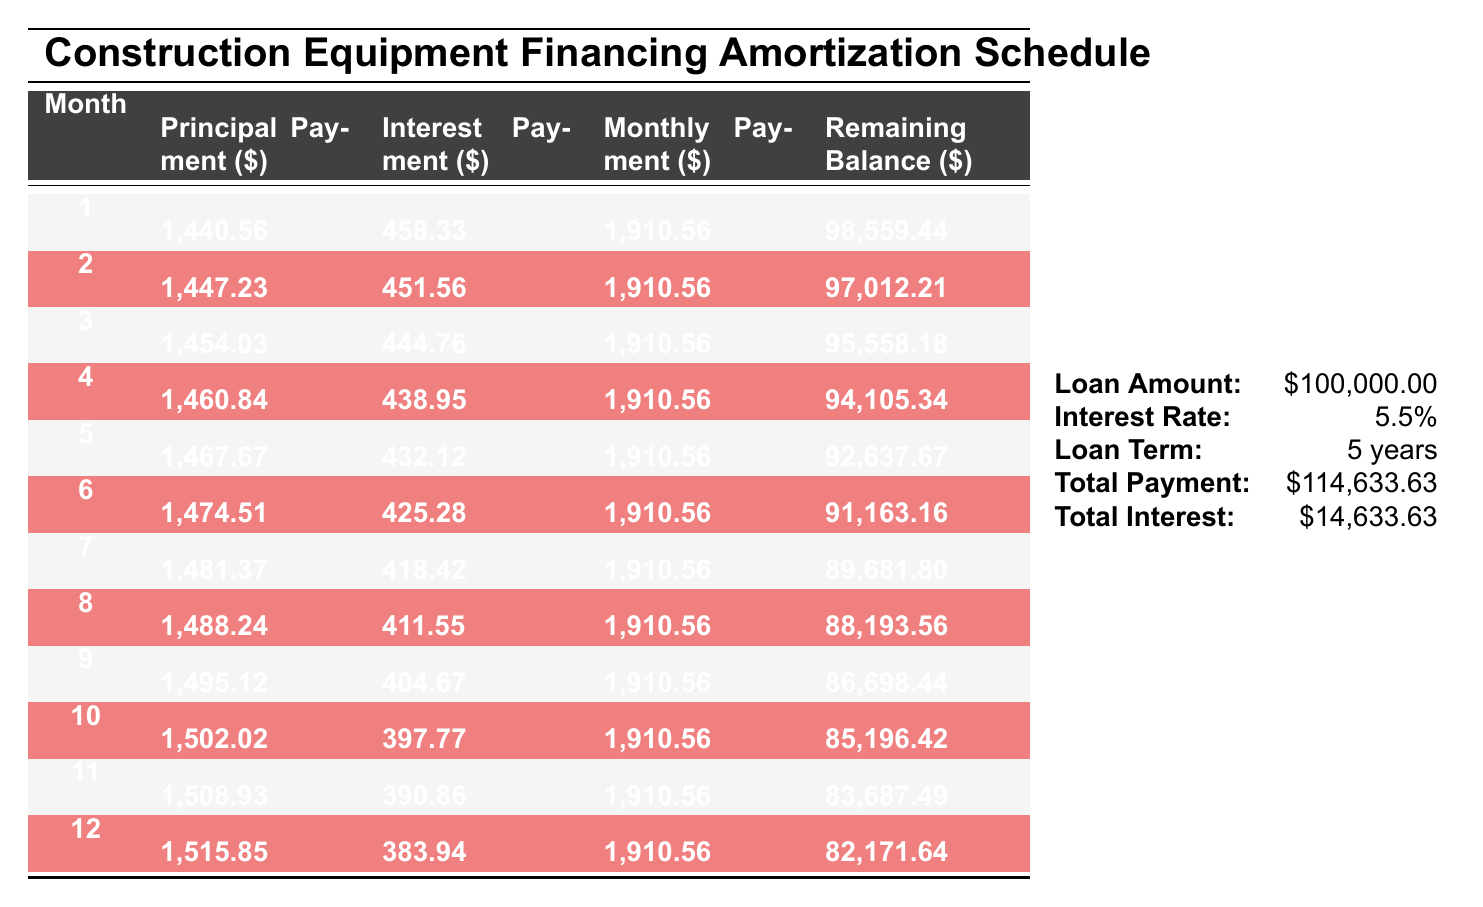What is the total amount paid by the end of the loan? The total amount paid is mentioned in the bottom table as $114,633.63.
Answer: 114,633.63 What is the interest payment for the first month? The interest payment for the first month is shown in the table as $458.33.
Answer: 458.33 How much principal is paid in the sixth month? The principal payment for the sixth month is indicated as $1,474.51 in the table.
Answer: 1,474.51 Is the interest payment decreasing each month? By looking at the interest payments across the months in the table, we see values starting from $458.33 in month 1 and decreasing consistently to $383.94 in month 12, confirming the trend of decreasing interest payments.
Answer: Yes What is the average monthly principal payment over the first 12 months? To calculate the average, sum the principal payments for the first 12 months: (1,440.56 + 1,447.23 + 1,454.03 + ... + 1,515.85) = 17,646.34. Divide this by 12 months gives an average of 17,646.34 / 12 = 1,470.53.
Answer: 1,470.53 What is the remaining balance after 10 months? The remaining balance after 10 months, as per the table, is listed as $85,196.42.
Answer: 85,196.42 How much total interest will be paid over the 5-year term? The total interest for the loan is provided in the bottom table as $14,633.63.
Answer: 14,633.63 What is the difference between the principal payment in the first month and the principal payment in the last month? The first month's principal payment is $1,440.56 and the last month's (12th month) is $1,515.85. The difference is $1,515.85 - $1,440.56 = $75.29.
Answer: 75.29 How many months will it take to pay off the loan entirely? The loan is structured to be paid off in 60 months since the loan term is 5 years.
Answer: 60 